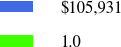<chart> <loc_0><loc_0><loc_500><loc_500><pie_chart><fcel>$105,931<fcel>1.0<nl><fcel>0.0%<fcel>100.0%<nl></chart> 